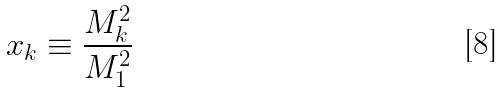Convert formula to latex. <formula><loc_0><loc_0><loc_500><loc_500>x _ { k } \equiv \frac { M _ { k } ^ { 2 } } { M _ { 1 } ^ { 2 } }</formula> 